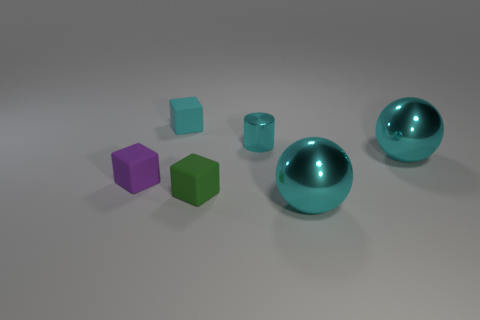How many cyan balls must be subtracted to get 1 cyan balls? 1 Subtract all spheres. How many objects are left? 4 Subtract all purple rubber cubes. How many cubes are left? 2 Subtract 1 cylinders. How many cylinders are left? 0 Subtract all yellow spheres. How many yellow blocks are left? 0 Subtract all large cyan metallic objects. Subtract all cubes. How many objects are left? 1 Add 6 tiny things. How many tiny things are left? 10 Add 3 red matte balls. How many red matte balls exist? 3 Add 2 small gray metal cylinders. How many objects exist? 8 Subtract 0 purple balls. How many objects are left? 6 